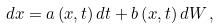<formula> <loc_0><loc_0><loc_500><loc_500>d { x } = { a } \left ( { x } , t \right ) d t + { b } \left ( { x } , t \right ) d { W } \, ,</formula> 